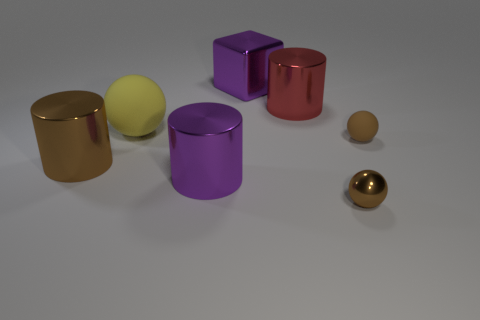Subtract all purple cylinders. How many cylinders are left? 2 Add 1 big brown metallic cubes. How many objects exist? 8 Subtract all yellow balls. Subtract all yellow blocks. How many balls are left? 2 Subtract all cyan balls. How many brown cylinders are left? 1 Subtract all cubes. Subtract all large gray shiny blocks. How many objects are left? 6 Add 5 big brown metallic cylinders. How many big brown metallic cylinders are left? 6 Add 4 small matte objects. How many small matte objects exist? 5 Subtract all brown cylinders. How many cylinders are left? 2 Subtract 2 brown spheres. How many objects are left? 5 Subtract all spheres. How many objects are left? 4 